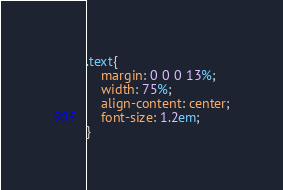<code> <loc_0><loc_0><loc_500><loc_500><_CSS_>.text{
    margin: 0 0 0 13%;
    width: 75%;
    align-content: center;
    font-size: 1.2em;
}
</code> 